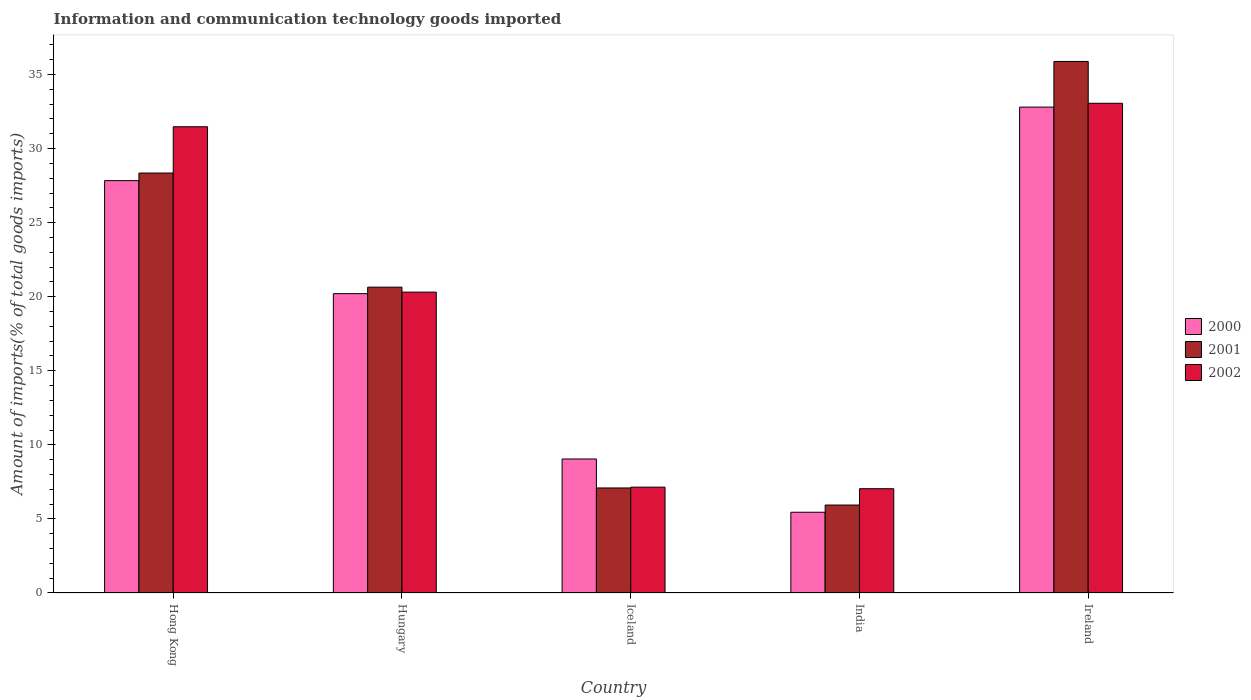How many different coloured bars are there?
Keep it short and to the point. 3. How many groups of bars are there?
Ensure brevity in your answer.  5. How many bars are there on the 3rd tick from the left?
Ensure brevity in your answer.  3. How many bars are there on the 4th tick from the right?
Keep it short and to the point. 3. What is the label of the 3rd group of bars from the left?
Your answer should be very brief. Iceland. What is the amount of goods imported in 2001 in India?
Give a very brief answer. 5.94. Across all countries, what is the maximum amount of goods imported in 2001?
Your answer should be very brief. 35.88. Across all countries, what is the minimum amount of goods imported in 2001?
Your answer should be very brief. 5.94. In which country was the amount of goods imported in 2001 maximum?
Provide a short and direct response. Ireland. In which country was the amount of goods imported in 2000 minimum?
Offer a terse response. India. What is the total amount of goods imported in 2001 in the graph?
Your answer should be compact. 97.9. What is the difference between the amount of goods imported in 2000 in Iceland and that in Ireland?
Your response must be concise. -23.75. What is the difference between the amount of goods imported in 2002 in Iceland and the amount of goods imported in 2001 in Hong Kong?
Provide a succinct answer. -21.2. What is the average amount of goods imported in 2001 per country?
Your response must be concise. 19.58. What is the difference between the amount of goods imported of/in 2000 and amount of goods imported of/in 2002 in Iceland?
Your answer should be compact. 1.9. In how many countries, is the amount of goods imported in 2000 greater than 33 %?
Offer a very short reply. 0. What is the ratio of the amount of goods imported in 2000 in Iceland to that in Ireland?
Keep it short and to the point. 0.28. What is the difference between the highest and the second highest amount of goods imported in 2002?
Ensure brevity in your answer.  12.75. What is the difference between the highest and the lowest amount of goods imported in 2000?
Provide a succinct answer. 27.35. What does the 3rd bar from the right in India represents?
Offer a terse response. 2000. Is it the case that in every country, the sum of the amount of goods imported in 2001 and amount of goods imported in 2000 is greater than the amount of goods imported in 2002?
Your answer should be compact. Yes. Are all the bars in the graph horizontal?
Your answer should be compact. No. How many countries are there in the graph?
Keep it short and to the point. 5. What is the difference between two consecutive major ticks on the Y-axis?
Keep it short and to the point. 5. Does the graph contain grids?
Ensure brevity in your answer.  No. Where does the legend appear in the graph?
Your answer should be very brief. Center right. How many legend labels are there?
Provide a succinct answer. 3. How are the legend labels stacked?
Your answer should be compact. Vertical. What is the title of the graph?
Keep it short and to the point. Information and communication technology goods imported. What is the label or title of the Y-axis?
Your answer should be very brief. Amount of imports(% of total goods imports). What is the Amount of imports(% of total goods imports) of 2000 in Hong Kong?
Your answer should be compact. 27.84. What is the Amount of imports(% of total goods imports) of 2001 in Hong Kong?
Your answer should be compact. 28.35. What is the Amount of imports(% of total goods imports) in 2002 in Hong Kong?
Ensure brevity in your answer.  31.47. What is the Amount of imports(% of total goods imports) of 2000 in Hungary?
Your response must be concise. 20.21. What is the Amount of imports(% of total goods imports) in 2001 in Hungary?
Provide a succinct answer. 20.65. What is the Amount of imports(% of total goods imports) of 2002 in Hungary?
Provide a short and direct response. 20.31. What is the Amount of imports(% of total goods imports) in 2000 in Iceland?
Offer a terse response. 9.05. What is the Amount of imports(% of total goods imports) in 2001 in Iceland?
Offer a terse response. 7.09. What is the Amount of imports(% of total goods imports) in 2002 in Iceland?
Offer a very short reply. 7.14. What is the Amount of imports(% of total goods imports) in 2000 in India?
Provide a short and direct response. 5.45. What is the Amount of imports(% of total goods imports) of 2001 in India?
Offer a very short reply. 5.94. What is the Amount of imports(% of total goods imports) in 2002 in India?
Keep it short and to the point. 7.04. What is the Amount of imports(% of total goods imports) in 2000 in Ireland?
Your response must be concise. 32.8. What is the Amount of imports(% of total goods imports) in 2001 in Ireland?
Offer a terse response. 35.88. What is the Amount of imports(% of total goods imports) of 2002 in Ireland?
Your answer should be very brief. 33.06. Across all countries, what is the maximum Amount of imports(% of total goods imports) in 2000?
Keep it short and to the point. 32.8. Across all countries, what is the maximum Amount of imports(% of total goods imports) in 2001?
Offer a terse response. 35.88. Across all countries, what is the maximum Amount of imports(% of total goods imports) of 2002?
Your answer should be compact. 33.06. Across all countries, what is the minimum Amount of imports(% of total goods imports) in 2000?
Offer a terse response. 5.45. Across all countries, what is the minimum Amount of imports(% of total goods imports) in 2001?
Provide a short and direct response. 5.94. Across all countries, what is the minimum Amount of imports(% of total goods imports) in 2002?
Make the answer very short. 7.04. What is the total Amount of imports(% of total goods imports) of 2000 in the graph?
Offer a very short reply. 95.34. What is the total Amount of imports(% of total goods imports) in 2001 in the graph?
Give a very brief answer. 97.9. What is the total Amount of imports(% of total goods imports) in 2002 in the graph?
Ensure brevity in your answer.  99.02. What is the difference between the Amount of imports(% of total goods imports) in 2000 in Hong Kong and that in Hungary?
Provide a succinct answer. 7.63. What is the difference between the Amount of imports(% of total goods imports) of 2001 in Hong Kong and that in Hungary?
Offer a very short reply. 7.7. What is the difference between the Amount of imports(% of total goods imports) in 2002 in Hong Kong and that in Hungary?
Give a very brief answer. 11.16. What is the difference between the Amount of imports(% of total goods imports) of 2000 in Hong Kong and that in Iceland?
Make the answer very short. 18.79. What is the difference between the Amount of imports(% of total goods imports) of 2001 in Hong Kong and that in Iceland?
Your answer should be very brief. 21.26. What is the difference between the Amount of imports(% of total goods imports) of 2002 in Hong Kong and that in Iceland?
Give a very brief answer. 24.33. What is the difference between the Amount of imports(% of total goods imports) in 2000 in Hong Kong and that in India?
Make the answer very short. 22.38. What is the difference between the Amount of imports(% of total goods imports) of 2001 in Hong Kong and that in India?
Your answer should be very brief. 22.41. What is the difference between the Amount of imports(% of total goods imports) in 2002 in Hong Kong and that in India?
Provide a short and direct response. 24.43. What is the difference between the Amount of imports(% of total goods imports) of 2000 in Hong Kong and that in Ireland?
Offer a terse response. -4.96. What is the difference between the Amount of imports(% of total goods imports) in 2001 in Hong Kong and that in Ireland?
Provide a succinct answer. -7.53. What is the difference between the Amount of imports(% of total goods imports) of 2002 in Hong Kong and that in Ireland?
Provide a succinct answer. -1.58. What is the difference between the Amount of imports(% of total goods imports) in 2000 in Hungary and that in Iceland?
Your response must be concise. 11.16. What is the difference between the Amount of imports(% of total goods imports) in 2001 in Hungary and that in Iceland?
Provide a succinct answer. 13.56. What is the difference between the Amount of imports(% of total goods imports) in 2002 in Hungary and that in Iceland?
Your answer should be very brief. 13.17. What is the difference between the Amount of imports(% of total goods imports) in 2000 in Hungary and that in India?
Your response must be concise. 14.76. What is the difference between the Amount of imports(% of total goods imports) of 2001 in Hungary and that in India?
Make the answer very short. 14.71. What is the difference between the Amount of imports(% of total goods imports) in 2002 in Hungary and that in India?
Keep it short and to the point. 13.27. What is the difference between the Amount of imports(% of total goods imports) in 2000 in Hungary and that in Ireland?
Give a very brief answer. -12.59. What is the difference between the Amount of imports(% of total goods imports) of 2001 in Hungary and that in Ireland?
Offer a terse response. -15.24. What is the difference between the Amount of imports(% of total goods imports) of 2002 in Hungary and that in Ireland?
Give a very brief answer. -12.75. What is the difference between the Amount of imports(% of total goods imports) of 2000 in Iceland and that in India?
Provide a short and direct response. 3.59. What is the difference between the Amount of imports(% of total goods imports) of 2001 in Iceland and that in India?
Offer a terse response. 1.15. What is the difference between the Amount of imports(% of total goods imports) in 2002 in Iceland and that in India?
Offer a very short reply. 0.11. What is the difference between the Amount of imports(% of total goods imports) in 2000 in Iceland and that in Ireland?
Ensure brevity in your answer.  -23.75. What is the difference between the Amount of imports(% of total goods imports) of 2001 in Iceland and that in Ireland?
Your response must be concise. -28.79. What is the difference between the Amount of imports(% of total goods imports) in 2002 in Iceland and that in Ireland?
Your answer should be very brief. -25.91. What is the difference between the Amount of imports(% of total goods imports) of 2000 in India and that in Ireland?
Provide a succinct answer. -27.35. What is the difference between the Amount of imports(% of total goods imports) in 2001 in India and that in Ireland?
Provide a short and direct response. -29.94. What is the difference between the Amount of imports(% of total goods imports) of 2002 in India and that in Ireland?
Provide a succinct answer. -26.02. What is the difference between the Amount of imports(% of total goods imports) of 2000 in Hong Kong and the Amount of imports(% of total goods imports) of 2001 in Hungary?
Your response must be concise. 7.19. What is the difference between the Amount of imports(% of total goods imports) in 2000 in Hong Kong and the Amount of imports(% of total goods imports) in 2002 in Hungary?
Keep it short and to the point. 7.53. What is the difference between the Amount of imports(% of total goods imports) of 2001 in Hong Kong and the Amount of imports(% of total goods imports) of 2002 in Hungary?
Your response must be concise. 8.04. What is the difference between the Amount of imports(% of total goods imports) of 2000 in Hong Kong and the Amount of imports(% of total goods imports) of 2001 in Iceland?
Provide a short and direct response. 20.75. What is the difference between the Amount of imports(% of total goods imports) in 2000 in Hong Kong and the Amount of imports(% of total goods imports) in 2002 in Iceland?
Your response must be concise. 20.69. What is the difference between the Amount of imports(% of total goods imports) of 2001 in Hong Kong and the Amount of imports(% of total goods imports) of 2002 in Iceland?
Make the answer very short. 21.2. What is the difference between the Amount of imports(% of total goods imports) of 2000 in Hong Kong and the Amount of imports(% of total goods imports) of 2001 in India?
Provide a short and direct response. 21.9. What is the difference between the Amount of imports(% of total goods imports) in 2000 in Hong Kong and the Amount of imports(% of total goods imports) in 2002 in India?
Provide a succinct answer. 20.8. What is the difference between the Amount of imports(% of total goods imports) of 2001 in Hong Kong and the Amount of imports(% of total goods imports) of 2002 in India?
Offer a terse response. 21.31. What is the difference between the Amount of imports(% of total goods imports) in 2000 in Hong Kong and the Amount of imports(% of total goods imports) in 2001 in Ireland?
Keep it short and to the point. -8.05. What is the difference between the Amount of imports(% of total goods imports) of 2000 in Hong Kong and the Amount of imports(% of total goods imports) of 2002 in Ireland?
Offer a terse response. -5.22. What is the difference between the Amount of imports(% of total goods imports) in 2001 in Hong Kong and the Amount of imports(% of total goods imports) in 2002 in Ireland?
Your response must be concise. -4.71. What is the difference between the Amount of imports(% of total goods imports) of 2000 in Hungary and the Amount of imports(% of total goods imports) of 2001 in Iceland?
Ensure brevity in your answer.  13.12. What is the difference between the Amount of imports(% of total goods imports) of 2000 in Hungary and the Amount of imports(% of total goods imports) of 2002 in Iceland?
Give a very brief answer. 13.06. What is the difference between the Amount of imports(% of total goods imports) in 2001 in Hungary and the Amount of imports(% of total goods imports) in 2002 in Iceland?
Ensure brevity in your answer.  13.5. What is the difference between the Amount of imports(% of total goods imports) of 2000 in Hungary and the Amount of imports(% of total goods imports) of 2001 in India?
Your answer should be very brief. 14.27. What is the difference between the Amount of imports(% of total goods imports) of 2000 in Hungary and the Amount of imports(% of total goods imports) of 2002 in India?
Provide a short and direct response. 13.17. What is the difference between the Amount of imports(% of total goods imports) in 2001 in Hungary and the Amount of imports(% of total goods imports) in 2002 in India?
Give a very brief answer. 13.61. What is the difference between the Amount of imports(% of total goods imports) in 2000 in Hungary and the Amount of imports(% of total goods imports) in 2001 in Ireland?
Provide a short and direct response. -15.67. What is the difference between the Amount of imports(% of total goods imports) of 2000 in Hungary and the Amount of imports(% of total goods imports) of 2002 in Ireland?
Offer a terse response. -12.85. What is the difference between the Amount of imports(% of total goods imports) in 2001 in Hungary and the Amount of imports(% of total goods imports) in 2002 in Ireland?
Your answer should be very brief. -12.41. What is the difference between the Amount of imports(% of total goods imports) in 2000 in Iceland and the Amount of imports(% of total goods imports) in 2001 in India?
Give a very brief answer. 3.11. What is the difference between the Amount of imports(% of total goods imports) of 2000 in Iceland and the Amount of imports(% of total goods imports) of 2002 in India?
Your response must be concise. 2.01. What is the difference between the Amount of imports(% of total goods imports) of 2001 in Iceland and the Amount of imports(% of total goods imports) of 2002 in India?
Provide a short and direct response. 0.05. What is the difference between the Amount of imports(% of total goods imports) of 2000 in Iceland and the Amount of imports(% of total goods imports) of 2001 in Ireland?
Your answer should be compact. -26.84. What is the difference between the Amount of imports(% of total goods imports) in 2000 in Iceland and the Amount of imports(% of total goods imports) in 2002 in Ireland?
Offer a very short reply. -24.01. What is the difference between the Amount of imports(% of total goods imports) in 2001 in Iceland and the Amount of imports(% of total goods imports) in 2002 in Ireland?
Your response must be concise. -25.97. What is the difference between the Amount of imports(% of total goods imports) in 2000 in India and the Amount of imports(% of total goods imports) in 2001 in Ireland?
Offer a terse response. -30.43. What is the difference between the Amount of imports(% of total goods imports) of 2000 in India and the Amount of imports(% of total goods imports) of 2002 in Ireland?
Provide a succinct answer. -27.61. What is the difference between the Amount of imports(% of total goods imports) in 2001 in India and the Amount of imports(% of total goods imports) in 2002 in Ireland?
Provide a short and direct response. -27.12. What is the average Amount of imports(% of total goods imports) in 2000 per country?
Give a very brief answer. 19.07. What is the average Amount of imports(% of total goods imports) of 2001 per country?
Offer a very short reply. 19.58. What is the average Amount of imports(% of total goods imports) in 2002 per country?
Your answer should be compact. 19.8. What is the difference between the Amount of imports(% of total goods imports) of 2000 and Amount of imports(% of total goods imports) of 2001 in Hong Kong?
Your response must be concise. -0.51. What is the difference between the Amount of imports(% of total goods imports) of 2000 and Amount of imports(% of total goods imports) of 2002 in Hong Kong?
Your response must be concise. -3.64. What is the difference between the Amount of imports(% of total goods imports) in 2001 and Amount of imports(% of total goods imports) in 2002 in Hong Kong?
Offer a terse response. -3.12. What is the difference between the Amount of imports(% of total goods imports) in 2000 and Amount of imports(% of total goods imports) in 2001 in Hungary?
Make the answer very short. -0.44. What is the difference between the Amount of imports(% of total goods imports) of 2000 and Amount of imports(% of total goods imports) of 2002 in Hungary?
Your answer should be very brief. -0.1. What is the difference between the Amount of imports(% of total goods imports) in 2001 and Amount of imports(% of total goods imports) in 2002 in Hungary?
Offer a terse response. 0.34. What is the difference between the Amount of imports(% of total goods imports) of 2000 and Amount of imports(% of total goods imports) of 2001 in Iceland?
Your answer should be very brief. 1.96. What is the difference between the Amount of imports(% of total goods imports) of 2000 and Amount of imports(% of total goods imports) of 2002 in Iceland?
Offer a terse response. 1.9. What is the difference between the Amount of imports(% of total goods imports) of 2001 and Amount of imports(% of total goods imports) of 2002 in Iceland?
Your answer should be very brief. -0.05. What is the difference between the Amount of imports(% of total goods imports) in 2000 and Amount of imports(% of total goods imports) in 2001 in India?
Ensure brevity in your answer.  -0.49. What is the difference between the Amount of imports(% of total goods imports) in 2000 and Amount of imports(% of total goods imports) in 2002 in India?
Make the answer very short. -1.59. What is the difference between the Amount of imports(% of total goods imports) in 2001 and Amount of imports(% of total goods imports) in 2002 in India?
Offer a terse response. -1.1. What is the difference between the Amount of imports(% of total goods imports) of 2000 and Amount of imports(% of total goods imports) of 2001 in Ireland?
Ensure brevity in your answer.  -3.08. What is the difference between the Amount of imports(% of total goods imports) of 2000 and Amount of imports(% of total goods imports) of 2002 in Ireland?
Give a very brief answer. -0.26. What is the difference between the Amount of imports(% of total goods imports) of 2001 and Amount of imports(% of total goods imports) of 2002 in Ireland?
Make the answer very short. 2.82. What is the ratio of the Amount of imports(% of total goods imports) of 2000 in Hong Kong to that in Hungary?
Your answer should be compact. 1.38. What is the ratio of the Amount of imports(% of total goods imports) of 2001 in Hong Kong to that in Hungary?
Ensure brevity in your answer.  1.37. What is the ratio of the Amount of imports(% of total goods imports) in 2002 in Hong Kong to that in Hungary?
Make the answer very short. 1.55. What is the ratio of the Amount of imports(% of total goods imports) in 2000 in Hong Kong to that in Iceland?
Your answer should be compact. 3.08. What is the ratio of the Amount of imports(% of total goods imports) in 2001 in Hong Kong to that in Iceland?
Your answer should be very brief. 4. What is the ratio of the Amount of imports(% of total goods imports) in 2002 in Hong Kong to that in Iceland?
Provide a short and direct response. 4.41. What is the ratio of the Amount of imports(% of total goods imports) of 2000 in Hong Kong to that in India?
Offer a very short reply. 5.11. What is the ratio of the Amount of imports(% of total goods imports) in 2001 in Hong Kong to that in India?
Ensure brevity in your answer.  4.78. What is the ratio of the Amount of imports(% of total goods imports) in 2002 in Hong Kong to that in India?
Offer a very short reply. 4.47. What is the ratio of the Amount of imports(% of total goods imports) of 2000 in Hong Kong to that in Ireland?
Provide a short and direct response. 0.85. What is the ratio of the Amount of imports(% of total goods imports) of 2001 in Hong Kong to that in Ireland?
Provide a short and direct response. 0.79. What is the ratio of the Amount of imports(% of total goods imports) of 2002 in Hong Kong to that in Ireland?
Your answer should be very brief. 0.95. What is the ratio of the Amount of imports(% of total goods imports) of 2000 in Hungary to that in Iceland?
Your answer should be very brief. 2.23. What is the ratio of the Amount of imports(% of total goods imports) in 2001 in Hungary to that in Iceland?
Provide a short and direct response. 2.91. What is the ratio of the Amount of imports(% of total goods imports) in 2002 in Hungary to that in Iceland?
Offer a very short reply. 2.84. What is the ratio of the Amount of imports(% of total goods imports) of 2000 in Hungary to that in India?
Ensure brevity in your answer.  3.71. What is the ratio of the Amount of imports(% of total goods imports) of 2001 in Hungary to that in India?
Make the answer very short. 3.48. What is the ratio of the Amount of imports(% of total goods imports) of 2002 in Hungary to that in India?
Provide a succinct answer. 2.89. What is the ratio of the Amount of imports(% of total goods imports) in 2000 in Hungary to that in Ireland?
Make the answer very short. 0.62. What is the ratio of the Amount of imports(% of total goods imports) of 2001 in Hungary to that in Ireland?
Provide a short and direct response. 0.58. What is the ratio of the Amount of imports(% of total goods imports) in 2002 in Hungary to that in Ireland?
Your response must be concise. 0.61. What is the ratio of the Amount of imports(% of total goods imports) in 2000 in Iceland to that in India?
Your response must be concise. 1.66. What is the ratio of the Amount of imports(% of total goods imports) in 2001 in Iceland to that in India?
Make the answer very short. 1.19. What is the ratio of the Amount of imports(% of total goods imports) in 2002 in Iceland to that in India?
Make the answer very short. 1.01. What is the ratio of the Amount of imports(% of total goods imports) in 2000 in Iceland to that in Ireland?
Offer a terse response. 0.28. What is the ratio of the Amount of imports(% of total goods imports) of 2001 in Iceland to that in Ireland?
Provide a short and direct response. 0.2. What is the ratio of the Amount of imports(% of total goods imports) of 2002 in Iceland to that in Ireland?
Make the answer very short. 0.22. What is the ratio of the Amount of imports(% of total goods imports) in 2000 in India to that in Ireland?
Offer a very short reply. 0.17. What is the ratio of the Amount of imports(% of total goods imports) of 2001 in India to that in Ireland?
Provide a short and direct response. 0.17. What is the ratio of the Amount of imports(% of total goods imports) of 2002 in India to that in Ireland?
Offer a terse response. 0.21. What is the difference between the highest and the second highest Amount of imports(% of total goods imports) of 2000?
Offer a terse response. 4.96. What is the difference between the highest and the second highest Amount of imports(% of total goods imports) in 2001?
Give a very brief answer. 7.53. What is the difference between the highest and the second highest Amount of imports(% of total goods imports) in 2002?
Your answer should be compact. 1.58. What is the difference between the highest and the lowest Amount of imports(% of total goods imports) of 2000?
Your response must be concise. 27.35. What is the difference between the highest and the lowest Amount of imports(% of total goods imports) of 2001?
Provide a succinct answer. 29.94. What is the difference between the highest and the lowest Amount of imports(% of total goods imports) of 2002?
Offer a very short reply. 26.02. 